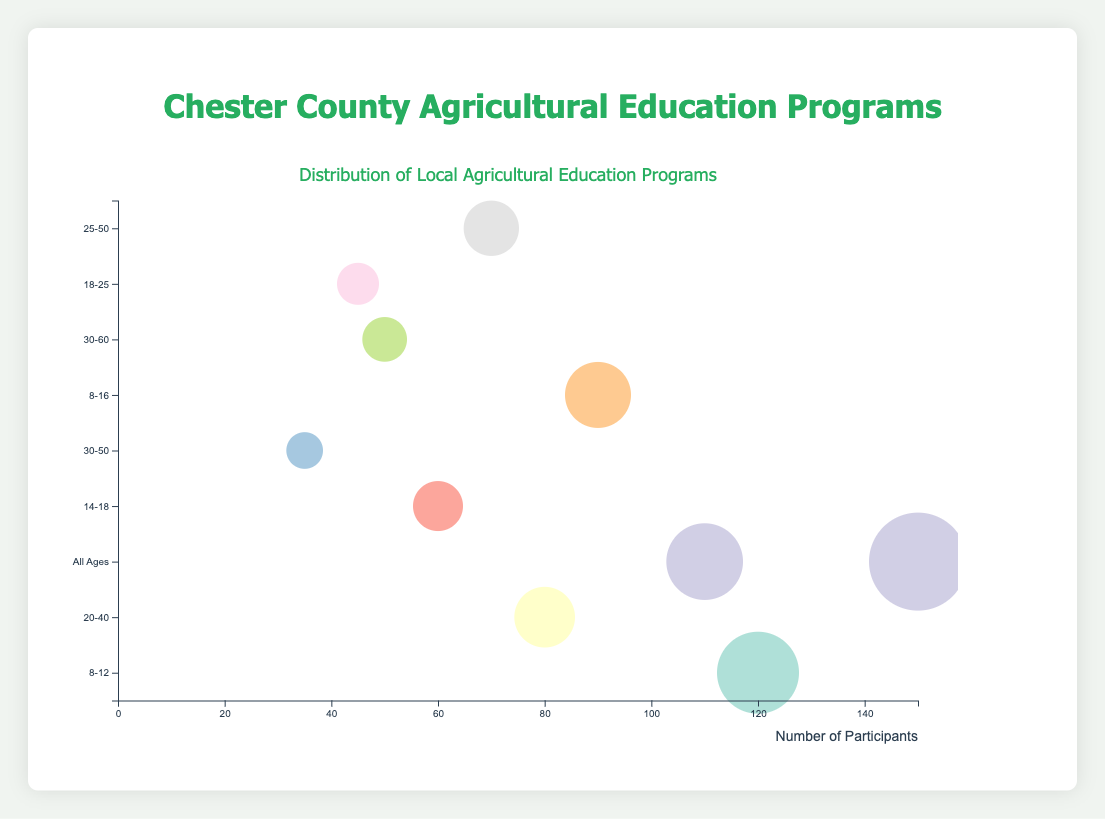What is the title of the bubble chart? The title is prominently displayed at the top of the chart.
Answer: Distribution of Local Agricultural Education Programs Which program has the largest number of participants? By looking at the size of the bubbles, the largest bubble represents "Great Valley Agricultural Fair Education Booths."
Answer: Great Valley Agricultural Fair Education Booths What age group is targeted by the "West Chester University Agri-Science Symposium"? Hovering over the bubble or checking its position on the y-axis reveals that this program targets the 18-25 age group.
Answer: 18-25 Which age group has the most programs catering to it? By counting the number of bubbles on the y-axis for each age group, we find which age group has the most programs.
Answer: All Ages How many programs target the "30-50" age group? By examining the bubbles aligned with the "30-50" age group on the y-axis, there are two programs: "Kennett Square Community Garden Classes" and "Malvern Sustainable Agriculture Lectures."
Answer: 2 Which program targets all age groups and has over 100 participants? By looking at the bubbles in the "All Ages" category and checking their sizes, "Unionville-Chadds Ford Farm-to-Table Program" matches the criteria.
Answer: Unionville-Chadds Ford Farm-to-Table Program What’s the total number of participants for programs targeting age group "30-50"? Adding up the participants of "Kennett Square Community Garden Classes" (35) and "Malvern Sustainable Agriculture Lectures" (70) gives the total.
Answer: 105 Compare the number of participants in the "Owen J. Roberts School Farm Tours" and the "Downingtown High School FFA Program." Which has more? By looking at the bubble sizes or values: "Owen J. Roberts School Farm Tours" has 90 participants, whereas "Downingtown High School FFA Program" has 60.
Answer: Owen J. Roberts School Farm Tours Which program directed at adults has the fewest participants? By checking the age groups that typically include adults (e.g., 20-40, 30-50, 30-60) and comparing bubble sizes, "West Chester University Agri-Science Symposium" (45 participants) is the smallest.
Answer: West Chester University Agri-Science Symposium How does the participant number of "Phoenixville Adult Education Organic Farming" compare to the "Malvern Sustainable Agriculture Lectures"? "Phoenixville Adult Education Organic Farming" has 50 participants, whereas "Malvern Sustainable Agriculture Lectures" has 70.
Answer: Malvern Sustainable Agriculture Lectures 